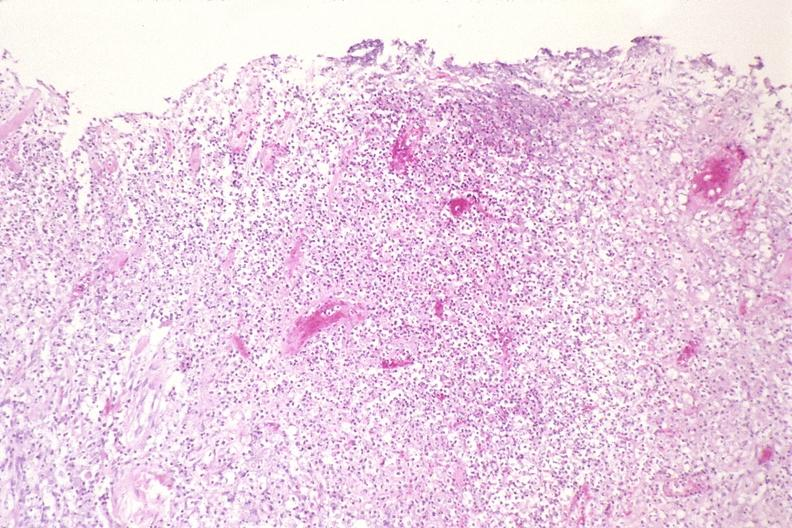does stomach show lung, histoplasma pneumonia?
Answer the question using a single word or phrase. No 